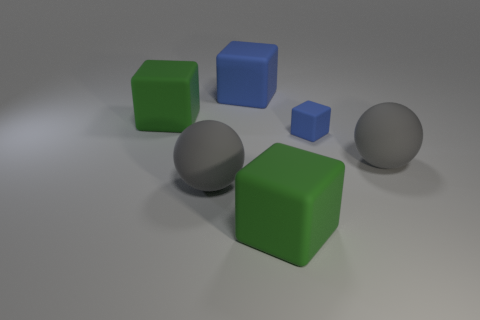The big matte ball behind the gray rubber thing that is left of the tiny blue rubber thing is what color?
Provide a succinct answer. Gray. What number of big rubber objects are both in front of the tiny blue thing and on the left side of the tiny blue matte object?
Provide a short and direct response. 2. How many other big blue rubber objects have the same shape as the large blue rubber thing?
Offer a very short reply. 0. Do the big blue thing and the small blue thing have the same material?
Provide a short and direct response. Yes. There is a gray matte object left of the rubber sphere on the right side of the tiny blue rubber object; what is its shape?
Your answer should be very brief. Sphere. What number of big gray rubber objects are to the left of the large rubber ball on the right side of the large blue matte block?
Provide a short and direct response. 1. The big rubber sphere that is on the left side of the tiny rubber block right of the big gray rubber ball that is left of the tiny blue matte thing is what color?
Give a very brief answer. Gray. What number of things are either big green matte things behind the tiny blue cube or gray matte balls?
Your response must be concise. 3. The tiny rubber thing has what color?
Offer a terse response. Blue. What number of large things are either blocks or gray spheres?
Your response must be concise. 5. 